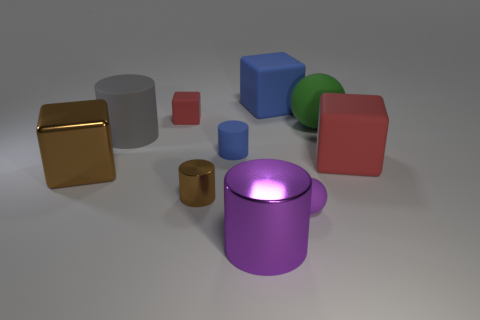Subtract all large metal blocks. How many blocks are left? 3 Subtract all green cylinders. How many red blocks are left? 2 Subtract 2 cylinders. How many cylinders are left? 2 Subtract all purple cylinders. How many cylinders are left? 3 Subtract all blocks. How many objects are left? 6 Subtract all yellow cylinders. Subtract all blue balls. How many cylinders are left? 4 Add 6 small cyan matte cubes. How many small cyan matte cubes exist? 6 Subtract 0 cyan cylinders. How many objects are left? 10 Subtract all yellow rubber spheres. Subtract all gray objects. How many objects are left? 9 Add 3 large matte spheres. How many large matte spheres are left? 4 